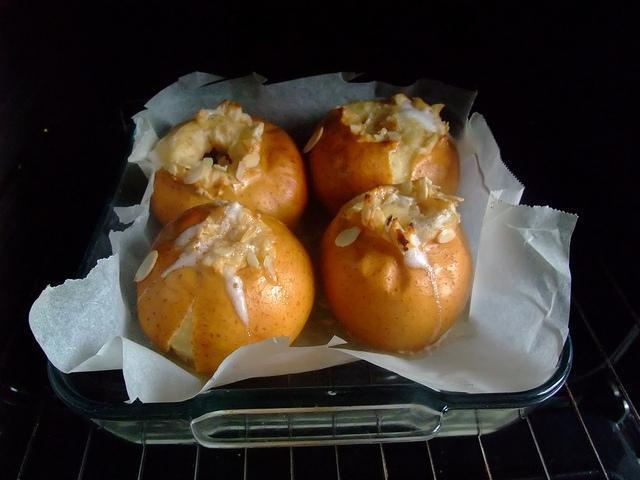How many donuts are there?
Give a very brief answer. 4. How many apples can be seen?
Give a very brief answer. 3. How many oranges are in the photo?
Give a very brief answer. 2. How many people are in the picture?
Give a very brief answer. 0. 